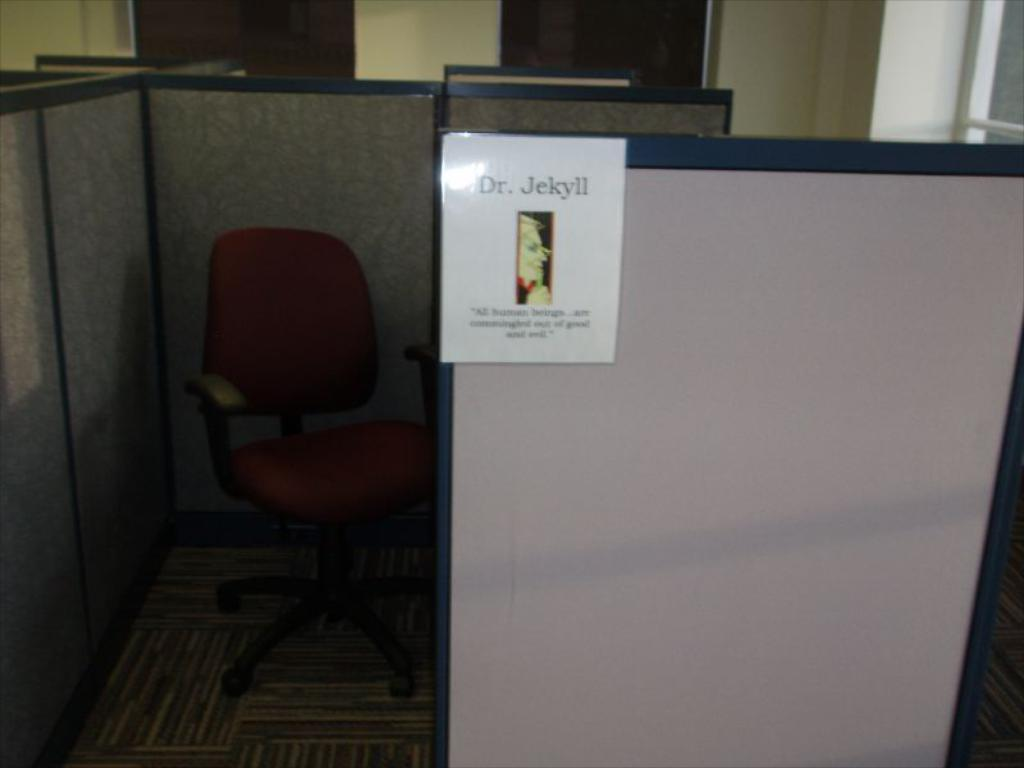<image>
Provide a brief description of the given image. A cubicle with a sign that says Dr. Jekyll 